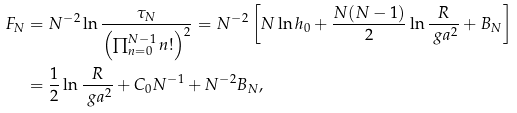<formula> <loc_0><loc_0><loc_500><loc_500>F _ { N } & = N ^ { - 2 } \ln \frac { \tau _ { N } } { \left ( \prod _ { n = 0 } ^ { N - 1 } n ! \right ) ^ { 2 } } = N ^ { - 2 } \left [ N \ln h _ { 0 } + \frac { N ( N - 1 ) } { 2 } \ln \frac { R } { \ g a ^ { 2 } } + B _ { N } \right ] \\ & = \frac { 1 } { 2 } \ln \frac { R } { \ g a ^ { 2 } } + C _ { 0 } N ^ { - 1 } + N ^ { - 2 } B _ { N } ,</formula> 